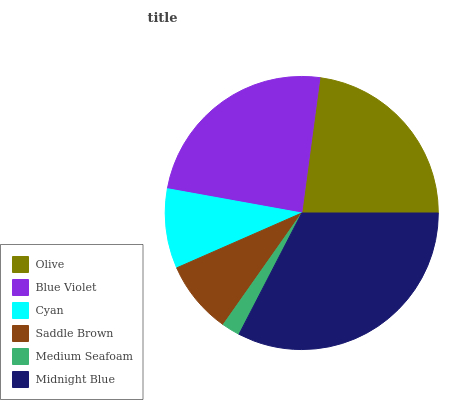Is Medium Seafoam the minimum?
Answer yes or no. Yes. Is Midnight Blue the maximum?
Answer yes or no. Yes. Is Blue Violet the minimum?
Answer yes or no. No. Is Blue Violet the maximum?
Answer yes or no. No. Is Blue Violet greater than Olive?
Answer yes or no. Yes. Is Olive less than Blue Violet?
Answer yes or no. Yes. Is Olive greater than Blue Violet?
Answer yes or no. No. Is Blue Violet less than Olive?
Answer yes or no. No. Is Olive the high median?
Answer yes or no. Yes. Is Cyan the low median?
Answer yes or no. Yes. Is Saddle Brown the high median?
Answer yes or no. No. Is Medium Seafoam the low median?
Answer yes or no. No. 